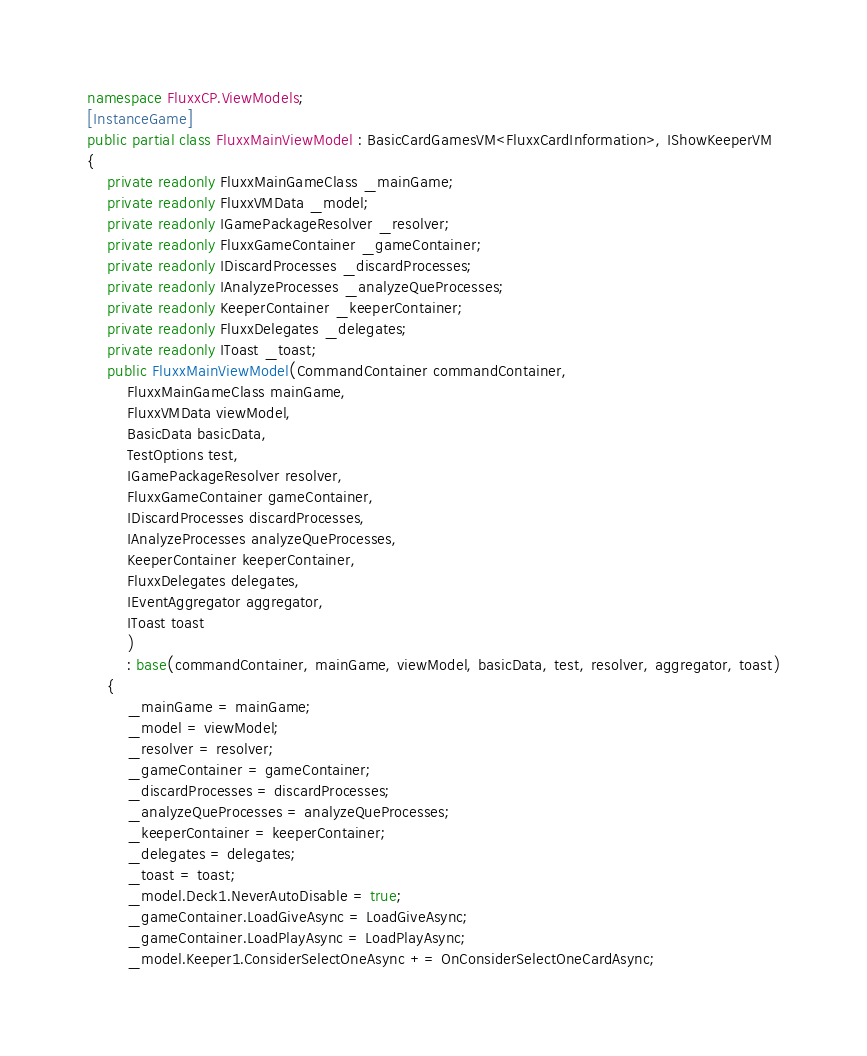Convert code to text. <code><loc_0><loc_0><loc_500><loc_500><_C#_>namespace FluxxCP.ViewModels;
[InstanceGame]
public partial class FluxxMainViewModel : BasicCardGamesVM<FluxxCardInformation>, IShowKeeperVM
{
    private readonly FluxxMainGameClass _mainGame;
    private readonly FluxxVMData _model;
    private readonly IGamePackageResolver _resolver;
    private readonly FluxxGameContainer _gameContainer;
    private readonly IDiscardProcesses _discardProcesses;
    private readonly IAnalyzeProcesses _analyzeQueProcesses;
    private readonly KeeperContainer _keeperContainer;
    private readonly FluxxDelegates _delegates;
    private readonly IToast _toast;
    public FluxxMainViewModel(CommandContainer commandContainer,
        FluxxMainGameClass mainGame,
        FluxxVMData viewModel,
        BasicData basicData,
        TestOptions test,
        IGamePackageResolver resolver,
        FluxxGameContainer gameContainer,
        IDiscardProcesses discardProcesses,
        IAnalyzeProcesses analyzeQueProcesses,
        KeeperContainer keeperContainer,
        FluxxDelegates delegates,
        IEventAggregator aggregator,
        IToast toast
        )
        : base(commandContainer, mainGame, viewModel, basicData, test, resolver, aggregator, toast)
    {
        _mainGame = mainGame;
        _model = viewModel;
        _resolver = resolver;
        _gameContainer = gameContainer;
        _discardProcesses = discardProcesses;
        _analyzeQueProcesses = analyzeQueProcesses;
        _keeperContainer = keeperContainer;
        _delegates = delegates;
        _toast = toast;
        _model.Deck1.NeverAutoDisable = true;
        _gameContainer.LoadGiveAsync = LoadGiveAsync;
        _gameContainer.LoadPlayAsync = LoadPlayAsync;
        _model.Keeper1.ConsiderSelectOneAsync += OnConsiderSelectOneCardAsync;</code> 